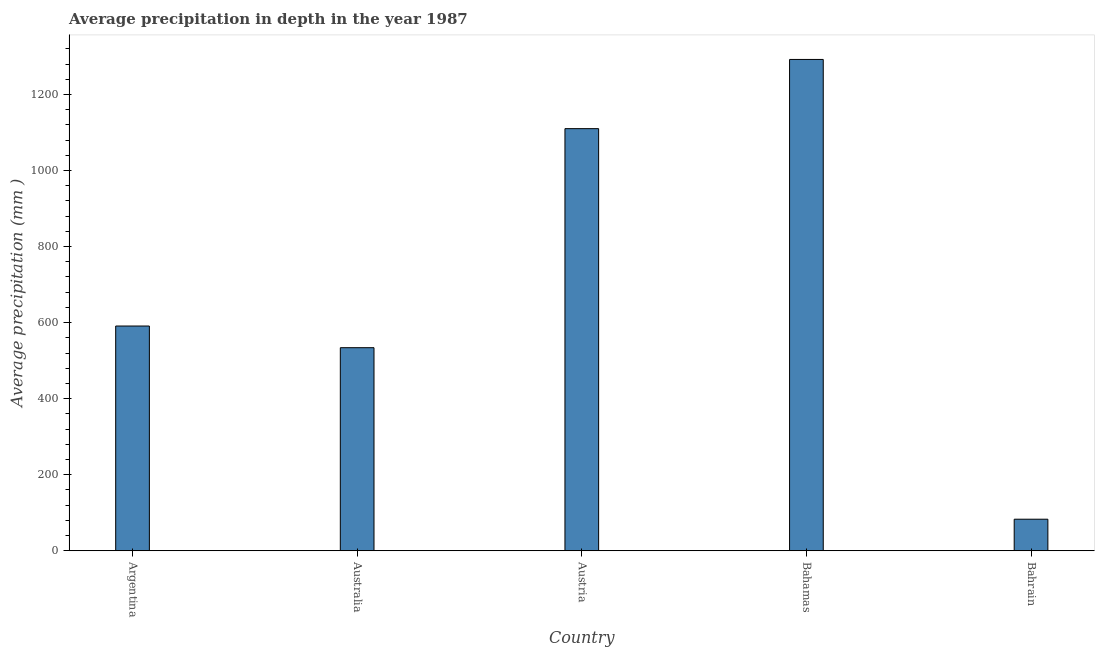What is the title of the graph?
Your answer should be compact. Average precipitation in depth in the year 1987. What is the label or title of the X-axis?
Offer a very short reply. Country. What is the label or title of the Y-axis?
Offer a terse response. Average precipitation (mm ). What is the average precipitation in depth in Argentina?
Offer a terse response. 591. Across all countries, what is the maximum average precipitation in depth?
Your answer should be very brief. 1292. Across all countries, what is the minimum average precipitation in depth?
Your response must be concise. 83. In which country was the average precipitation in depth maximum?
Your response must be concise. Bahamas. In which country was the average precipitation in depth minimum?
Offer a very short reply. Bahrain. What is the sum of the average precipitation in depth?
Provide a succinct answer. 3610. What is the difference between the average precipitation in depth in Argentina and Austria?
Offer a terse response. -519. What is the average average precipitation in depth per country?
Give a very brief answer. 722. What is the median average precipitation in depth?
Your response must be concise. 591. What is the ratio of the average precipitation in depth in Australia to that in Austria?
Your answer should be compact. 0.48. Is the average precipitation in depth in Argentina less than that in Austria?
Provide a succinct answer. Yes. Is the difference between the average precipitation in depth in Argentina and Bahrain greater than the difference between any two countries?
Keep it short and to the point. No. What is the difference between the highest and the second highest average precipitation in depth?
Provide a short and direct response. 182. Is the sum of the average precipitation in depth in Austria and Bahamas greater than the maximum average precipitation in depth across all countries?
Your answer should be compact. Yes. What is the difference between the highest and the lowest average precipitation in depth?
Provide a short and direct response. 1209. In how many countries, is the average precipitation in depth greater than the average average precipitation in depth taken over all countries?
Give a very brief answer. 2. How many bars are there?
Your answer should be very brief. 5. What is the difference between two consecutive major ticks on the Y-axis?
Provide a short and direct response. 200. What is the Average precipitation (mm ) in Argentina?
Make the answer very short. 591. What is the Average precipitation (mm ) of Australia?
Keep it short and to the point. 534. What is the Average precipitation (mm ) of Austria?
Provide a short and direct response. 1110. What is the Average precipitation (mm ) in Bahamas?
Give a very brief answer. 1292. What is the Average precipitation (mm ) in Bahrain?
Your answer should be compact. 83. What is the difference between the Average precipitation (mm ) in Argentina and Austria?
Offer a terse response. -519. What is the difference between the Average precipitation (mm ) in Argentina and Bahamas?
Offer a very short reply. -701. What is the difference between the Average precipitation (mm ) in Argentina and Bahrain?
Offer a terse response. 508. What is the difference between the Average precipitation (mm ) in Australia and Austria?
Ensure brevity in your answer.  -576. What is the difference between the Average precipitation (mm ) in Australia and Bahamas?
Your answer should be very brief. -758. What is the difference between the Average precipitation (mm ) in Australia and Bahrain?
Your response must be concise. 451. What is the difference between the Average precipitation (mm ) in Austria and Bahamas?
Keep it short and to the point. -182. What is the difference between the Average precipitation (mm ) in Austria and Bahrain?
Provide a succinct answer. 1027. What is the difference between the Average precipitation (mm ) in Bahamas and Bahrain?
Ensure brevity in your answer.  1209. What is the ratio of the Average precipitation (mm ) in Argentina to that in Australia?
Keep it short and to the point. 1.11. What is the ratio of the Average precipitation (mm ) in Argentina to that in Austria?
Offer a terse response. 0.53. What is the ratio of the Average precipitation (mm ) in Argentina to that in Bahamas?
Offer a very short reply. 0.46. What is the ratio of the Average precipitation (mm ) in Argentina to that in Bahrain?
Keep it short and to the point. 7.12. What is the ratio of the Average precipitation (mm ) in Australia to that in Austria?
Provide a short and direct response. 0.48. What is the ratio of the Average precipitation (mm ) in Australia to that in Bahamas?
Keep it short and to the point. 0.41. What is the ratio of the Average precipitation (mm ) in Australia to that in Bahrain?
Keep it short and to the point. 6.43. What is the ratio of the Average precipitation (mm ) in Austria to that in Bahamas?
Your response must be concise. 0.86. What is the ratio of the Average precipitation (mm ) in Austria to that in Bahrain?
Your answer should be compact. 13.37. What is the ratio of the Average precipitation (mm ) in Bahamas to that in Bahrain?
Give a very brief answer. 15.57. 